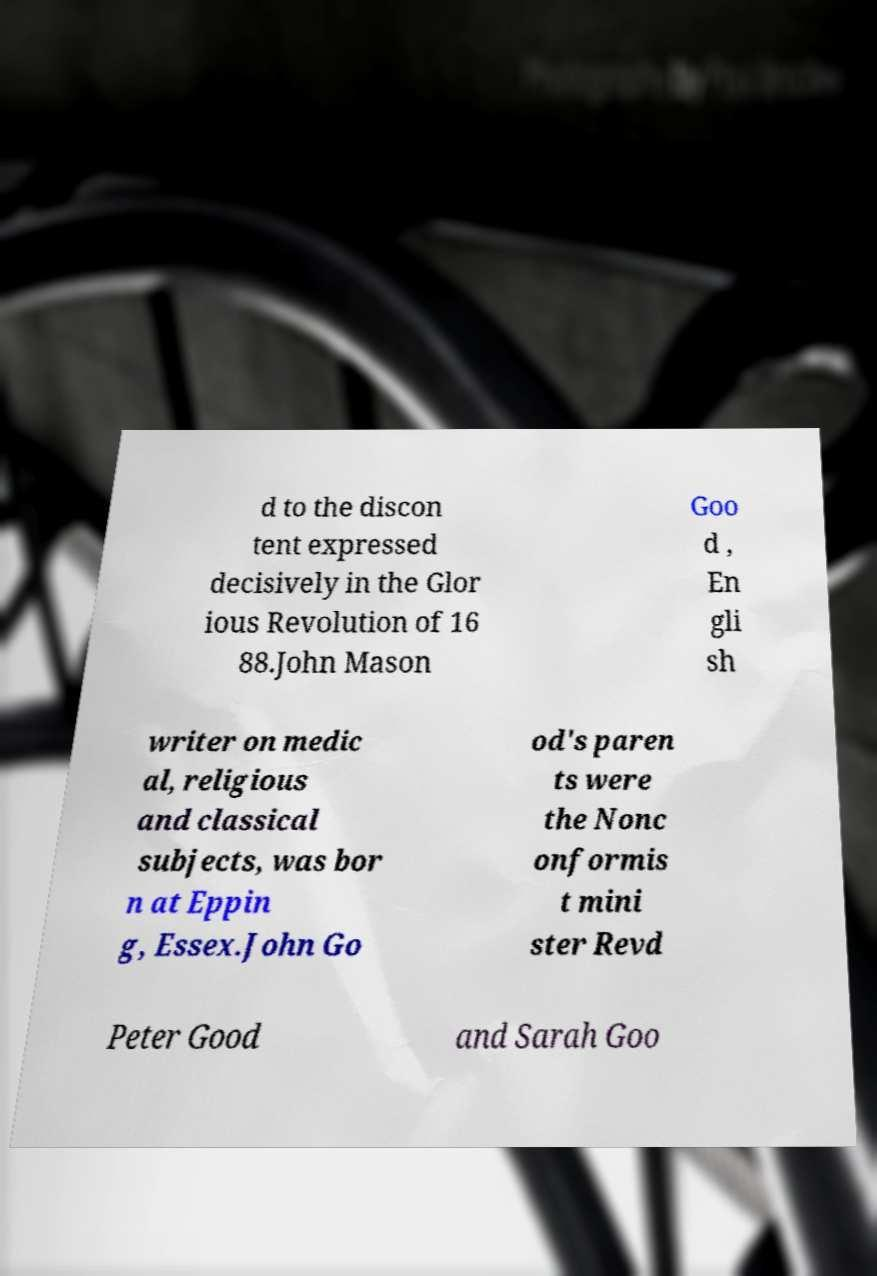Please read and relay the text visible in this image. What does it say? d to the discon tent expressed decisively in the Glor ious Revolution of 16 88.John Mason Goo d , En gli sh writer on medic al, religious and classical subjects, was bor n at Eppin g, Essex.John Go od's paren ts were the Nonc onformis t mini ster Revd Peter Good and Sarah Goo 